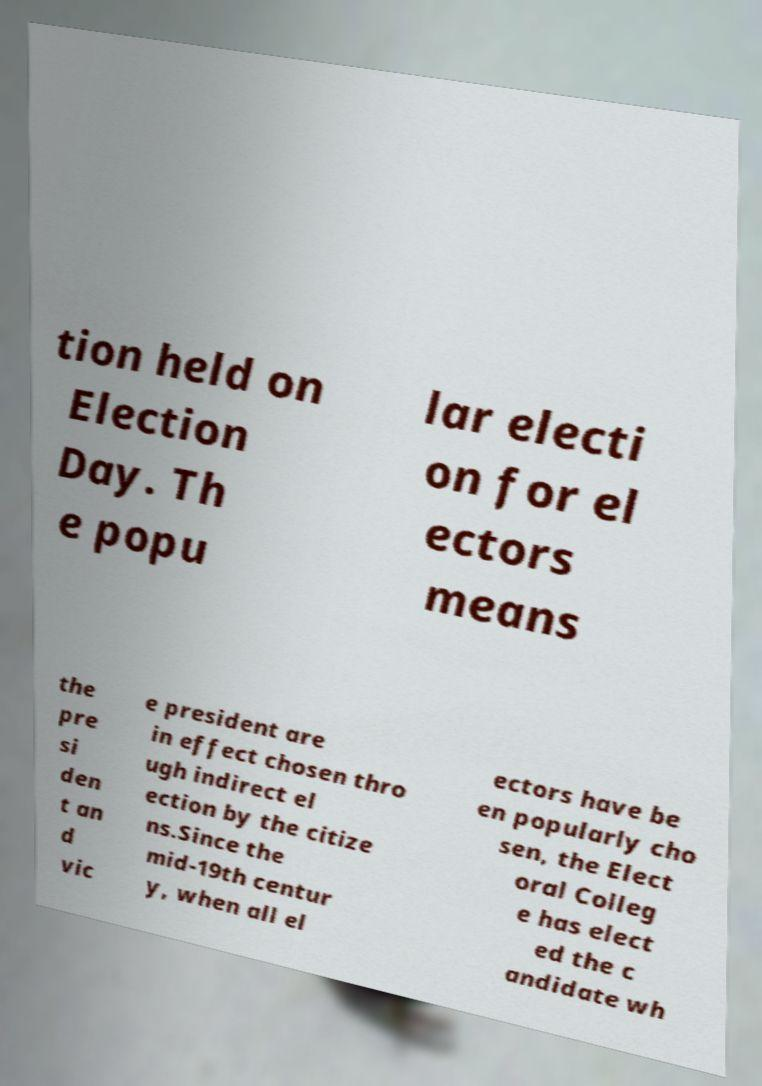I need the written content from this picture converted into text. Can you do that? tion held on Election Day. Th e popu lar electi on for el ectors means the pre si den t an d vic e president are in effect chosen thro ugh indirect el ection by the citize ns.Since the mid-19th centur y, when all el ectors have be en popularly cho sen, the Elect oral Colleg e has elect ed the c andidate wh 